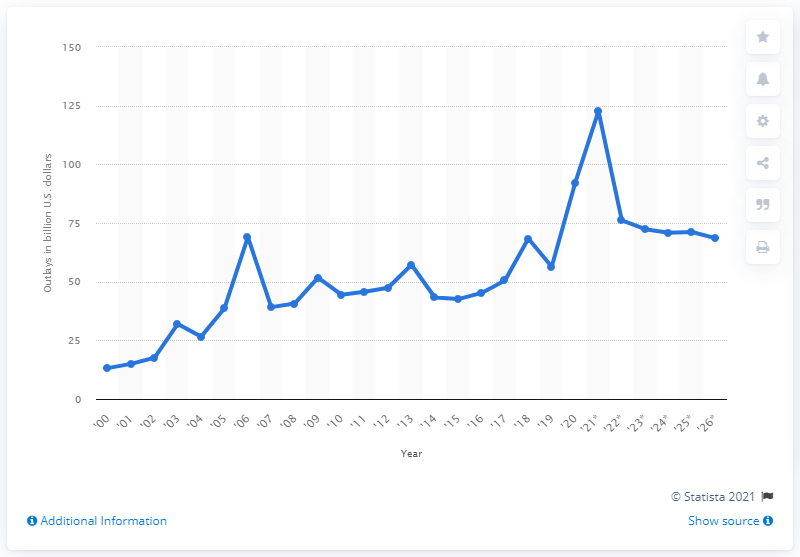Mention a couple of crucial points in this snapshot. In 2020, the Department of Homeland Security spent a total of $91.97 million. In 2021, the Department of Homeland Security is expected to spend a total of $122.71. 